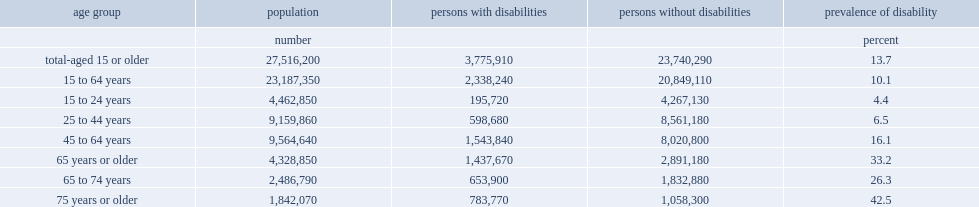What was the prevalence of disability among 15- to 24-year-olds? 4.4. What was the prevalence of disability for persons aged 75 years or older? 42.5. Which group had a higher prevalence of disability, persons aged 75 years or older or persons among 15- to 24-year-olds? 75 years or older. What percentage of people of working age (15 to 64 years) reported having a disability? 10.1. What percentage of people reported having a disability among the senior population (65 years or older)? 33.2. 